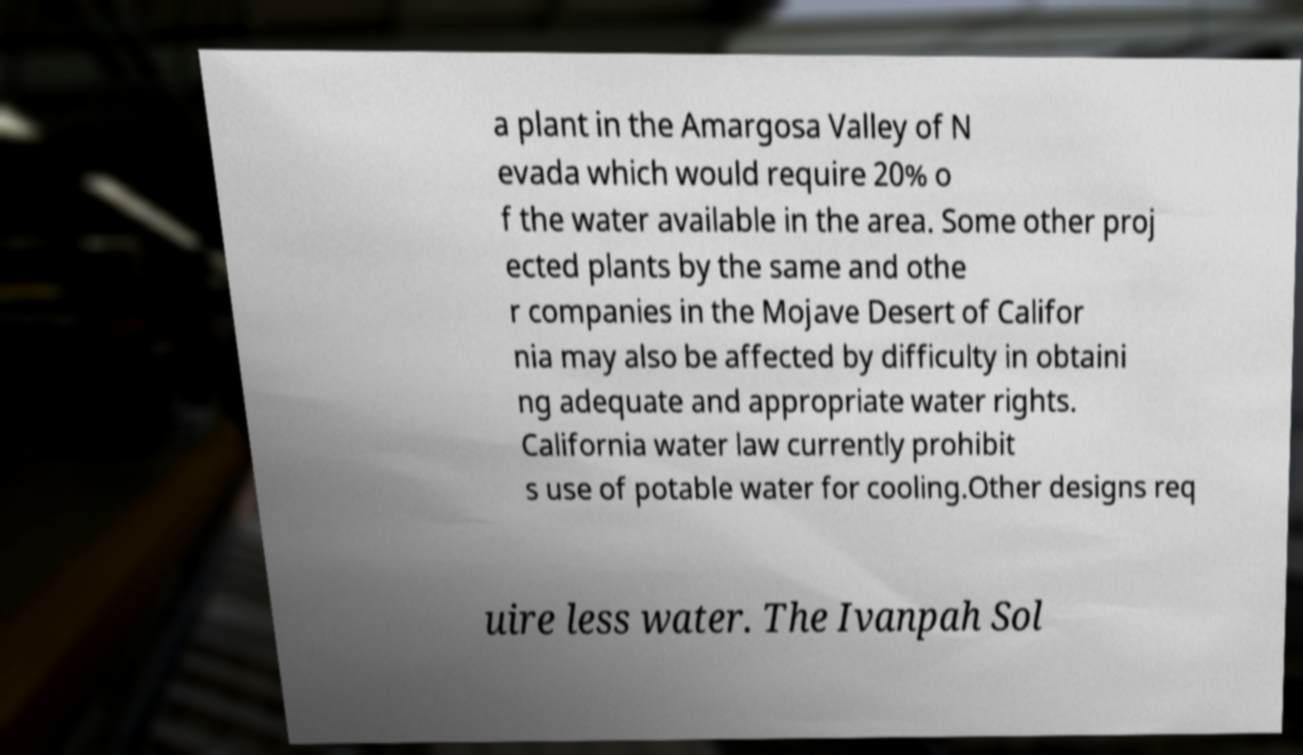Please read and relay the text visible in this image. What does it say? a plant in the Amargosa Valley of N evada which would require 20% o f the water available in the area. Some other proj ected plants by the same and othe r companies in the Mojave Desert of Califor nia may also be affected by difficulty in obtaini ng adequate and appropriate water rights. California water law currently prohibit s use of potable water for cooling.Other designs req uire less water. The Ivanpah Sol 